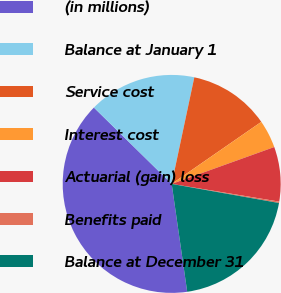Convert chart. <chart><loc_0><loc_0><loc_500><loc_500><pie_chart><fcel>(in millions)<fcel>Balance at January 1<fcel>Service cost<fcel>Interest cost<fcel>Actuarial (gain) loss<fcel>Benefits paid<fcel>Balance at December 31<nl><fcel>39.63%<fcel>15.98%<fcel>12.03%<fcel>4.15%<fcel>8.09%<fcel>0.21%<fcel>19.92%<nl></chart> 